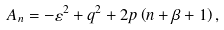<formula> <loc_0><loc_0><loc_500><loc_500>A _ { n } = - \varepsilon ^ { 2 } + q ^ { 2 } + 2 p \left ( n + \beta + 1 \right ) ,</formula> 